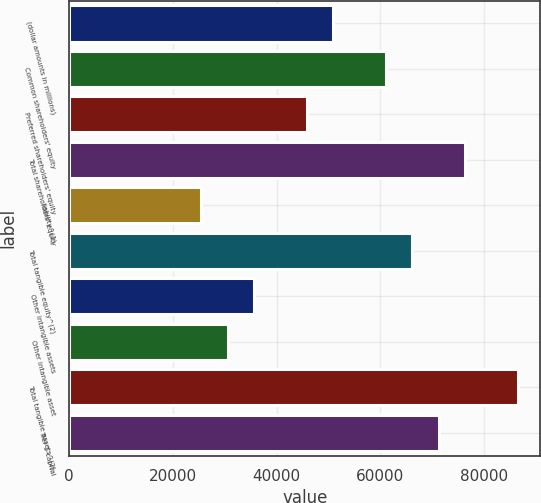Convert chart. <chart><loc_0><loc_0><loc_500><loc_500><bar_chart><fcel>(dollar amounts in millions)<fcel>Common shareholders' equity<fcel>Preferred shareholders' equity<fcel>Total shareholders' equity<fcel>liability^(1)<fcel>Total tangible equity^(2)<fcel>Other intangible assets<fcel>Other intangible asset<fcel>Total tangible assets^(2)<fcel>Tier 1 capital<nl><fcel>50923<fcel>61106.4<fcel>45831.3<fcel>76381.6<fcel>25464.5<fcel>66198.1<fcel>35647.9<fcel>30556.2<fcel>86565<fcel>71289.9<nl></chart> 